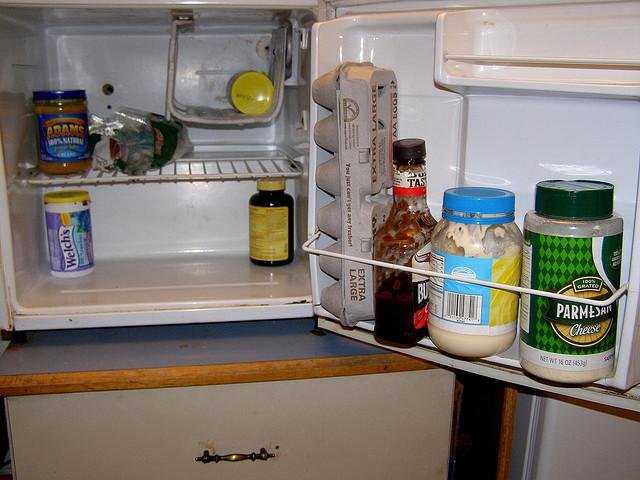How many objects here contain items from the dairy group? two 